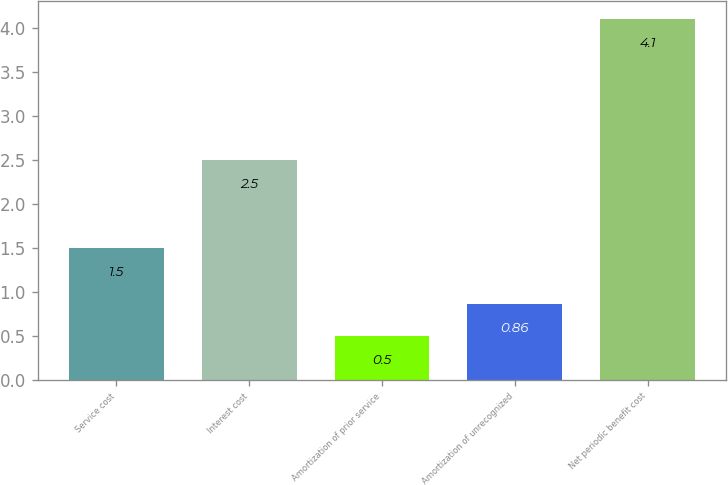Convert chart to OTSL. <chart><loc_0><loc_0><loc_500><loc_500><bar_chart><fcel>Service cost<fcel>Interest cost<fcel>Amortization of prior service<fcel>Amortization of unrecognized<fcel>Net periodic benefit cost<nl><fcel>1.5<fcel>2.5<fcel>0.5<fcel>0.86<fcel>4.1<nl></chart> 